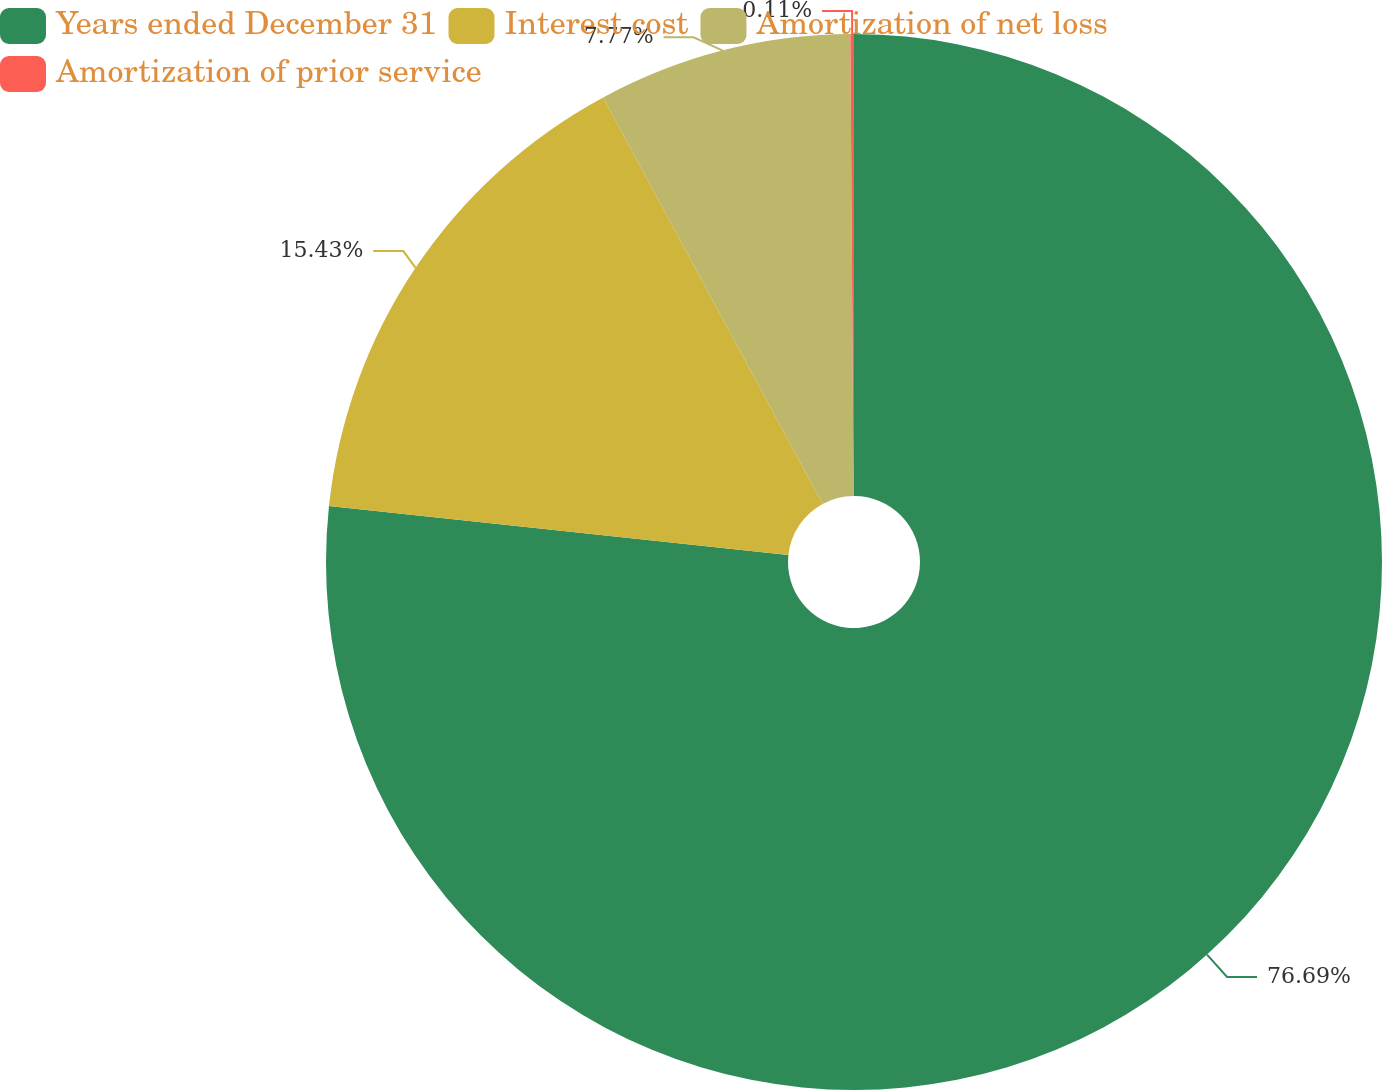Convert chart to OTSL. <chart><loc_0><loc_0><loc_500><loc_500><pie_chart><fcel>Years ended December 31<fcel>Interest cost<fcel>Amortization of net loss<fcel>Amortization of prior service<nl><fcel>76.69%<fcel>15.43%<fcel>7.77%<fcel>0.11%<nl></chart> 